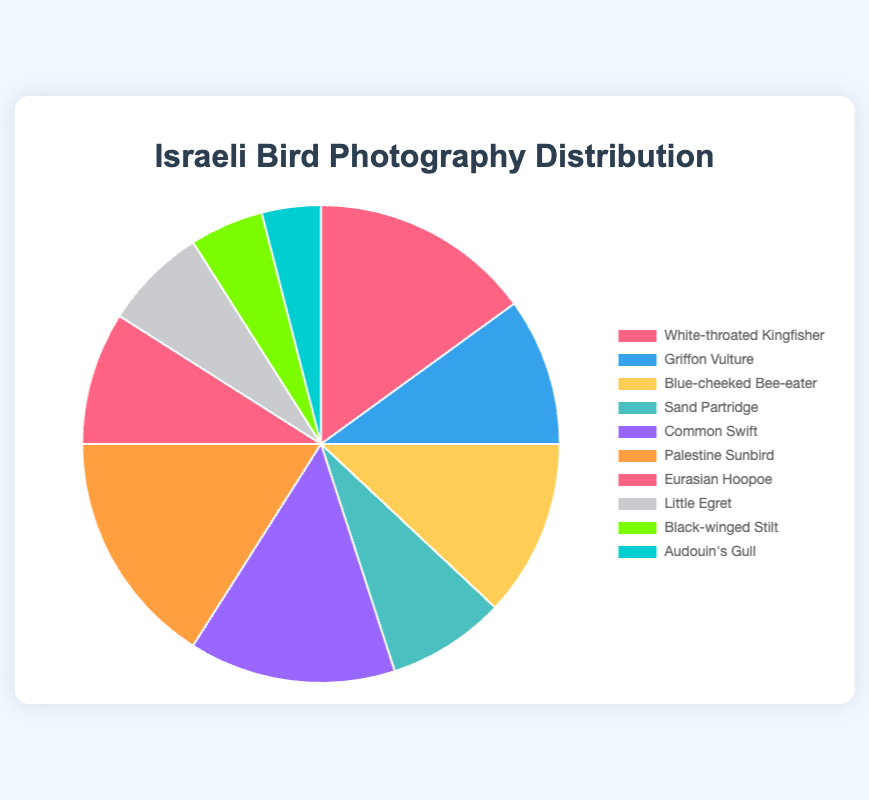What percentage of the photographed birds are either Common Swift or Blue-cheeked Bee-eater? The percentage of Common Swift is 14% and Blue-cheeked Bee-eater is 12%. Adding these together gives 14% + 12% = 26%.
Answer: 26% Which bird has the highest representation in the photography dataset? The Palestine Sunbird has the highest percentage which is 16%.
Answer: Palestine Sunbird How many birds have a representation percentage larger than 10%? The birds with more than 10% are White-throated Kingfisher (15%), Common Swift (14%), Blue-cheeked Bee-eater (12%), and Palestine Sunbird (16%). This totals to 4 birds.
Answer: 4 Which bird type has a higher percentage, Griffon Vulture or Eurasian Hoopoe? Griffon Vulture has a percentage of 10% and Eurasian Hoopoe has 9%. Since 10% is greater than 9%, the Griffon Vulture has a higher percentage.
Answer: Griffon Vulture How does the percentage representation of Black-winged Stilt compare to Little Egret? Black-winged Stilt is 5% and Little Egret is 7%. Since 5% is less than 7%, Black-winged Stilt has a lower representation.
Answer: Black-winged Stilt What is the combined percentage of the three least represented bird types in the photography? The three least represented bird types are Audouin's Gull (4%), Black-winged Stilt (5%), and Little Egret (7%). Adding these percentages gives 4% + 5% + 7% = 16%.
Answer: 16% If you were to double the percentage of White-throated Kingfisher, what would be the new combined percentage of White-throated Kingfisher and Palestine Sunbird? The original percentage of White-throated Kingfisher is 15%. Doubling it gives 15% * 2 = 30%. Adding this to the Palestine Sunbird percentage of 16% results in 30% + 16% = 46%.
Answer: 46% Which two bird types have the closest percentage representation? Sand Partridge has 8% and Eurasian Hoopoe has 9%, with a difference of 1%. These two bird types have the closest percentage representations.
Answer: Sand Partridge and Eurasian Hoopoe Which bird represented by a percentage below 10% is visually depicted in green color on the pie chart? From the chart's color description, the bird depicted in green is the Black-winged Stilt which has a 5% representation.
Answer: Black-winged Stilt 